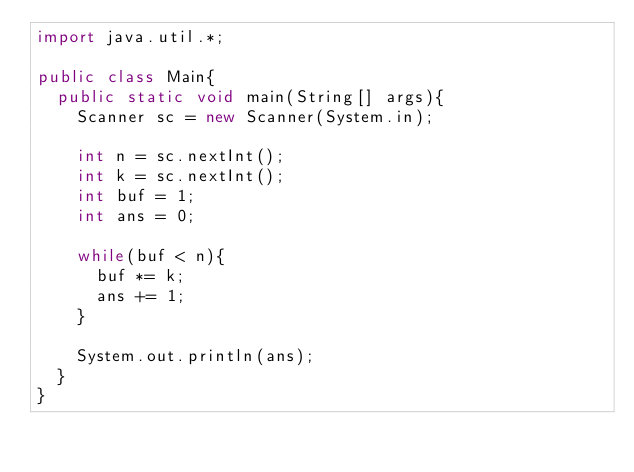<code> <loc_0><loc_0><loc_500><loc_500><_Java_>import java.util.*;

public class Main{
  public static void main(String[] args){
    Scanner sc = new Scanner(System.in);

    int n = sc.nextInt();
    int k = sc.nextInt();
    int buf = 1;
    int ans = 0;

    while(buf < n){
      buf *= k;
      ans += 1;
    }

    System.out.println(ans);
  }
}
</code> 